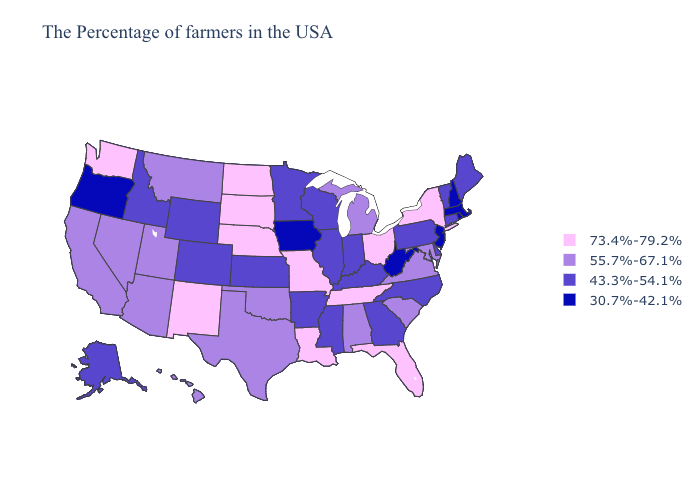Among the states that border California , which have the highest value?
Write a very short answer. Arizona, Nevada. Name the states that have a value in the range 30.7%-42.1%?
Give a very brief answer. Massachusetts, Rhode Island, New Hampshire, New Jersey, West Virginia, Iowa, Oregon. What is the highest value in the South ?
Answer briefly. 73.4%-79.2%. Does Mississippi have the highest value in the USA?
Answer briefly. No. What is the value of New Mexico?
Keep it brief. 73.4%-79.2%. Among the states that border Delaware , which have the highest value?
Concise answer only. Maryland. What is the value of Wyoming?
Keep it brief. 43.3%-54.1%. What is the highest value in the Northeast ?
Short answer required. 73.4%-79.2%. What is the value of Indiana?
Keep it brief. 43.3%-54.1%. Name the states that have a value in the range 43.3%-54.1%?
Give a very brief answer. Maine, Vermont, Connecticut, Delaware, Pennsylvania, North Carolina, Georgia, Kentucky, Indiana, Wisconsin, Illinois, Mississippi, Arkansas, Minnesota, Kansas, Wyoming, Colorado, Idaho, Alaska. Does Wisconsin have the lowest value in the USA?
Quick response, please. No. Name the states that have a value in the range 43.3%-54.1%?
Be succinct. Maine, Vermont, Connecticut, Delaware, Pennsylvania, North Carolina, Georgia, Kentucky, Indiana, Wisconsin, Illinois, Mississippi, Arkansas, Minnesota, Kansas, Wyoming, Colorado, Idaho, Alaska. What is the highest value in states that border Nevada?
Write a very short answer. 55.7%-67.1%. What is the value of Colorado?
Concise answer only. 43.3%-54.1%. Name the states that have a value in the range 43.3%-54.1%?
Answer briefly. Maine, Vermont, Connecticut, Delaware, Pennsylvania, North Carolina, Georgia, Kentucky, Indiana, Wisconsin, Illinois, Mississippi, Arkansas, Minnesota, Kansas, Wyoming, Colorado, Idaho, Alaska. 